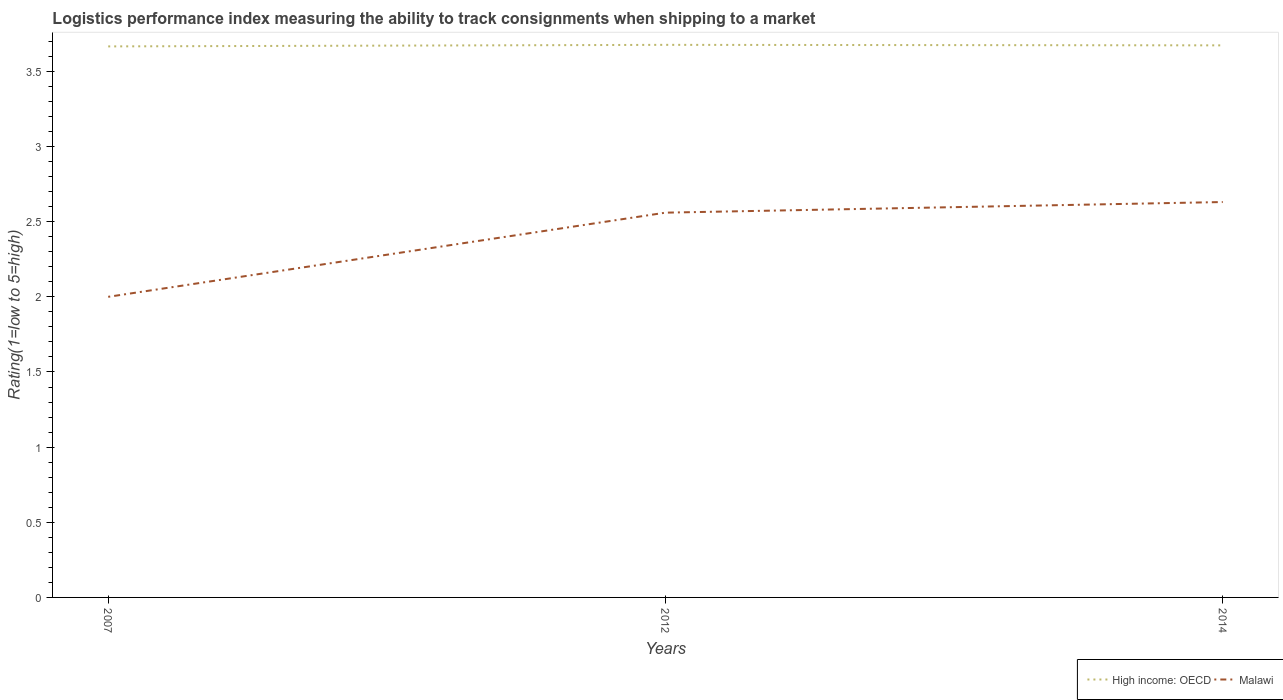Is the number of lines equal to the number of legend labels?
Offer a terse response. Yes. Across all years, what is the maximum Logistic performance index in High income: OECD?
Your response must be concise. 3.67. What is the total Logistic performance index in Malawi in the graph?
Provide a short and direct response. -0.63. What is the difference between the highest and the second highest Logistic performance index in High income: OECD?
Your answer should be compact. 0.01. What is the difference between the highest and the lowest Logistic performance index in Malawi?
Offer a very short reply. 2. How many lines are there?
Your answer should be compact. 2. Does the graph contain grids?
Your answer should be compact. No. Where does the legend appear in the graph?
Provide a short and direct response. Bottom right. How many legend labels are there?
Your answer should be very brief. 2. What is the title of the graph?
Your answer should be compact. Logistics performance index measuring the ability to track consignments when shipping to a market. What is the label or title of the X-axis?
Provide a short and direct response. Years. What is the label or title of the Y-axis?
Give a very brief answer. Rating(1=low to 5=high). What is the Rating(1=low to 5=high) of High income: OECD in 2007?
Your answer should be compact. 3.67. What is the Rating(1=low to 5=high) in High income: OECD in 2012?
Ensure brevity in your answer.  3.68. What is the Rating(1=low to 5=high) of Malawi in 2012?
Your response must be concise. 2.56. What is the Rating(1=low to 5=high) in High income: OECD in 2014?
Provide a short and direct response. 3.67. What is the Rating(1=low to 5=high) in Malawi in 2014?
Ensure brevity in your answer.  2.63. Across all years, what is the maximum Rating(1=low to 5=high) of High income: OECD?
Offer a very short reply. 3.68. Across all years, what is the maximum Rating(1=low to 5=high) of Malawi?
Keep it short and to the point. 2.63. Across all years, what is the minimum Rating(1=low to 5=high) in High income: OECD?
Your response must be concise. 3.67. Across all years, what is the minimum Rating(1=low to 5=high) of Malawi?
Ensure brevity in your answer.  2. What is the total Rating(1=low to 5=high) in High income: OECD in the graph?
Your answer should be very brief. 11.02. What is the total Rating(1=low to 5=high) of Malawi in the graph?
Your answer should be compact. 7.19. What is the difference between the Rating(1=low to 5=high) in High income: OECD in 2007 and that in 2012?
Offer a terse response. -0.01. What is the difference between the Rating(1=low to 5=high) in Malawi in 2007 and that in 2012?
Your response must be concise. -0.56. What is the difference between the Rating(1=low to 5=high) in High income: OECD in 2007 and that in 2014?
Provide a short and direct response. -0.01. What is the difference between the Rating(1=low to 5=high) in Malawi in 2007 and that in 2014?
Ensure brevity in your answer.  -0.63. What is the difference between the Rating(1=low to 5=high) of High income: OECD in 2012 and that in 2014?
Provide a short and direct response. 0. What is the difference between the Rating(1=low to 5=high) in Malawi in 2012 and that in 2014?
Ensure brevity in your answer.  -0.07. What is the difference between the Rating(1=low to 5=high) in High income: OECD in 2007 and the Rating(1=low to 5=high) in Malawi in 2012?
Provide a short and direct response. 1.11. What is the difference between the Rating(1=low to 5=high) of High income: OECD in 2007 and the Rating(1=low to 5=high) of Malawi in 2014?
Provide a succinct answer. 1.04. What is the difference between the Rating(1=low to 5=high) in High income: OECD in 2012 and the Rating(1=low to 5=high) in Malawi in 2014?
Your response must be concise. 1.05. What is the average Rating(1=low to 5=high) in High income: OECD per year?
Ensure brevity in your answer.  3.67. What is the average Rating(1=low to 5=high) in Malawi per year?
Offer a very short reply. 2.4. In the year 2007, what is the difference between the Rating(1=low to 5=high) of High income: OECD and Rating(1=low to 5=high) of Malawi?
Keep it short and to the point. 1.67. In the year 2012, what is the difference between the Rating(1=low to 5=high) in High income: OECD and Rating(1=low to 5=high) in Malawi?
Your answer should be compact. 1.12. In the year 2014, what is the difference between the Rating(1=low to 5=high) in High income: OECD and Rating(1=low to 5=high) in Malawi?
Provide a succinct answer. 1.04. What is the ratio of the Rating(1=low to 5=high) in High income: OECD in 2007 to that in 2012?
Provide a succinct answer. 1. What is the ratio of the Rating(1=low to 5=high) of Malawi in 2007 to that in 2012?
Provide a succinct answer. 0.78. What is the ratio of the Rating(1=low to 5=high) in Malawi in 2007 to that in 2014?
Make the answer very short. 0.76. What is the ratio of the Rating(1=low to 5=high) of Malawi in 2012 to that in 2014?
Give a very brief answer. 0.97. What is the difference between the highest and the second highest Rating(1=low to 5=high) in High income: OECD?
Offer a terse response. 0. What is the difference between the highest and the second highest Rating(1=low to 5=high) in Malawi?
Make the answer very short. 0.07. What is the difference between the highest and the lowest Rating(1=low to 5=high) of High income: OECD?
Your answer should be compact. 0.01. What is the difference between the highest and the lowest Rating(1=low to 5=high) of Malawi?
Provide a succinct answer. 0.63. 